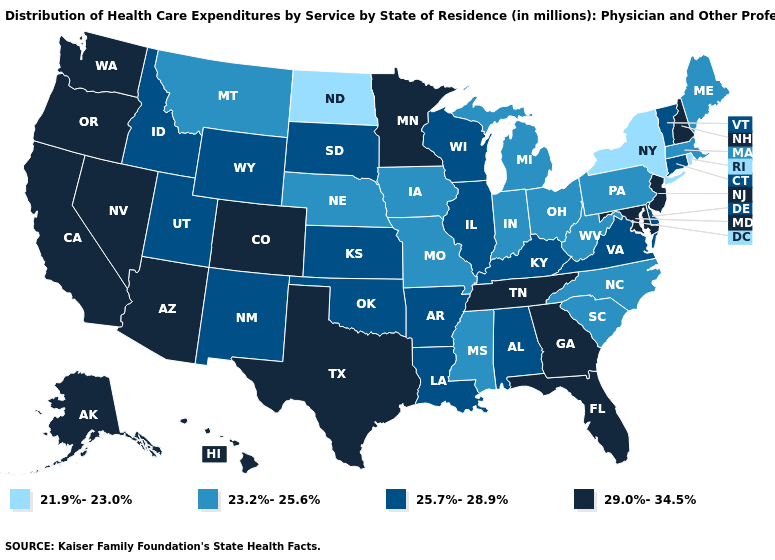Name the states that have a value in the range 23.2%-25.6%?
Quick response, please. Indiana, Iowa, Maine, Massachusetts, Michigan, Mississippi, Missouri, Montana, Nebraska, North Carolina, Ohio, Pennsylvania, South Carolina, West Virginia. Does Minnesota have the same value as Georgia?
Write a very short answer. Yes. Does Georgia have the highest value in the South?
Be succinct. Yes. Is the legend a continuous bar?
Give a very brief answer. No. Does Pennsylvania have a higher value than Michigan?
Quick response, please. No. Name the states that have a value in the range 25.7%-28.9%?
Keep it brief. Alabama, Arkansas, Connecticut, Delaware, Idaho, Illinois, Kansas, Kentucky, Louisiana, New Mexico, Oklahoma, South Dakota, Utah, Vermont, Virginia, Wisconsin, Wyoming. Name the states that have a value in the range 21.9%-23.0%?
Keep it brief. New York, North Dakota, Rhode Island. Name the states that have a value in the range 25.7%-28.9%?
Be succinct. Alabama, Arkansas, Connecticut, Delaware, Idaho, Illinois, Kansas, Kentucky, Louisiana, New Mexico, Oklahoma, South Dakota, Utah, Vermont, Virginia, Wisconsin, Wyoming. What is the value of Virginia?
Keep it brief. 25.7%-28.9%. What is the value of Tennessee?
Answer briefly. 29.0%-34.5%. Does the map have missing data?
Answer briefly. No. Name the states that have a value in the range 29.0%-34.5%?
Short answer required. Alaska, Arizona, California, Colorado, Florida, Georgia, Hawaii, Maryland, Minnesota, Nevada, New Hampshire, New Jersey, Oregon, Tennessee, Texas, Washington. Does North Dakota have the lowest value in the USA?
Give a very brief answer. Yes. Among the states that border Pennsylvania , does New York have the lowest value?
Quick response, please. Yes. Which states have the highest value in the USA?
Be succinct. Alaska, Arizona, California, Colorado, Florida, Georgia, Hawaii, Maryland, Minnesota, Nevada, New Hampshire, New Jersey, Oregon, Tennessee, Texas, Washington. 